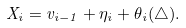<formula> <loc_0><loc_0><loc_500><loc_500>X _ { i } = v _ { i - 1 } + \eta _ { i } + \theta _ { i } ( \triangle ) .</formula> 